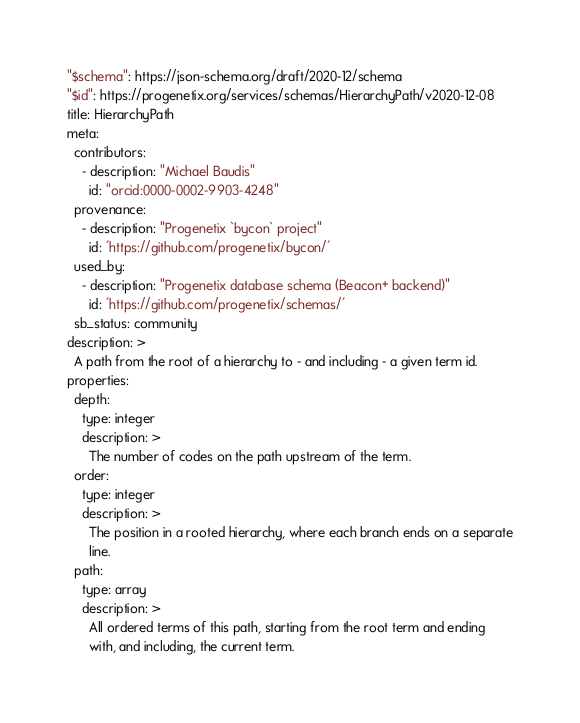<code> <loc_0><loc_0><loc_500><loc_500><_YAML_>"$schema": https://json-schema.org/draft/2020-12/schema
"$id": https://progenetix.org/services/schemas/HierarchyPath/v2020-12-08
title: HierarchyPath
meta:
  contributors:
    - description: "Michael Baudis"
      id: "orcid:0000-0002-9903-4248"
  provenance:
    - description: "Progenetix `bycon` project"
      id: 'https://github.com/progenetix/bycon/'
  used_by:
    - description: "Progenetix database schema (Beacon+ backend)"
      id: 'https://github.com/progenetix/schemas/'
  sb_status: community
description: >
  A path from the root of a hierarchy to - and including - a given term id.
properties:
  depth:
    type: integer
    description: >
      The number of codes on the path upstream of the term.
  order:
    type: integer
    description: >
      The position in a rooted hierarchy, where each branch ends on a separate
      line.
  path:
    type: array
    description: >
      All ordered terms of this path, starting from the root term and ending
      with, and including, the current term.
</code> 